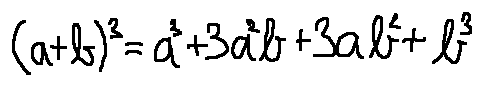Convert formula to latex. <formula><loc_0><loc_0><loc_500><loc_500>( a + b ) ^ { 3 } = a ^ { 3 } + 3 a ^ { 2 } b + 3 a b ^ { 2 } + b ^ { 3 }</formula> 